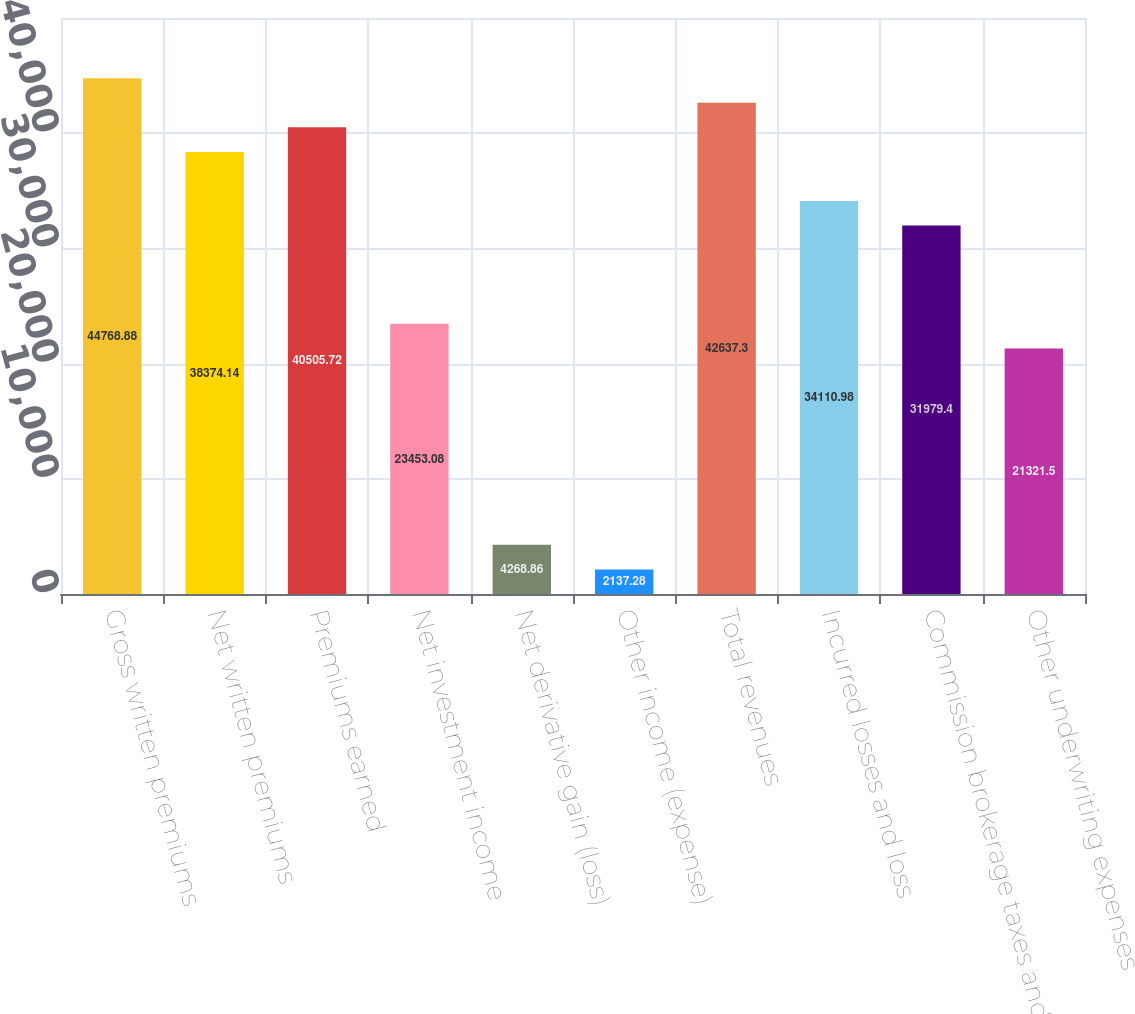<chart> <loc_0><loc_0><loc_500><loc_500><bar_chart><fcel>Gross written premiums<fcel>Net written premiums<fcel>Premiums earned<fcel>Net investment income<fcel>Net derivative gain (loss)<fcel>Other income (expense)<fcel>Total revenues<fcel>Incurred losses and loss<fcel>Commission brokerage taxes and<fcel>Other underwriting expenses<nl><fcel>44768.9<fcel>38374.1<fcel>40505.7<fcel>23453.1<fcel>4268.86<fcel>2137.28<fcel>42637.3<fcel>34111<fcel>31979.4<fcel>21321.5<nl></chart> 